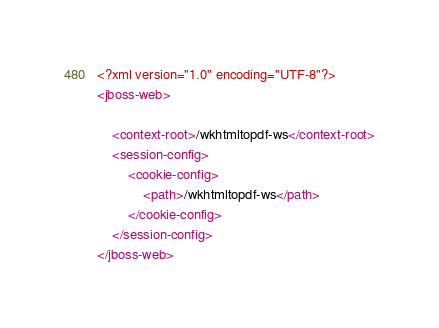Convert code to text. <code><loc_0><loc_0><loc_500><loc_500><_XML_><?xml version="1.0" encoding="UTF-8"?>
<jboss-web>

    <context-root>/wkhtmltopdf-ws</context-root>
    <session-config>
        <cookie-config>
            <path>/wkhtmltopdf-ws</path>
        </cookie-config>
    </session-config>
</jboss-web>
</code> 